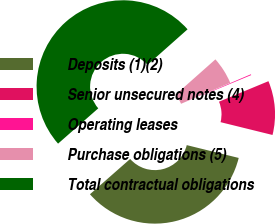<chart> <loc_0><loc_0><loc_500><loc_500><pie_chart><fcel>Deposits (1)(2)<fcel>Senior unsecured notes (4)<fcel>Operating leases<fcel>Purchase obligations (5)<fcel>Total contractual obligations<nl><fcel>34.68%<fcel>10.11%<fcel>0.16%<fcel>5.13%<fcel>49.92%<nl></chart> 